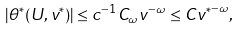Convert formula to latex. <formula><loc_0><loc_0><loc_500><loc_500>| \theta ^ { * } ( U , v ^ { * } ) | \leq c ^ { - 1 } C _ { \omega } v ^ { - \omega } \leq C { v ^ { * } } ^ { - \omega } ,</formula> 